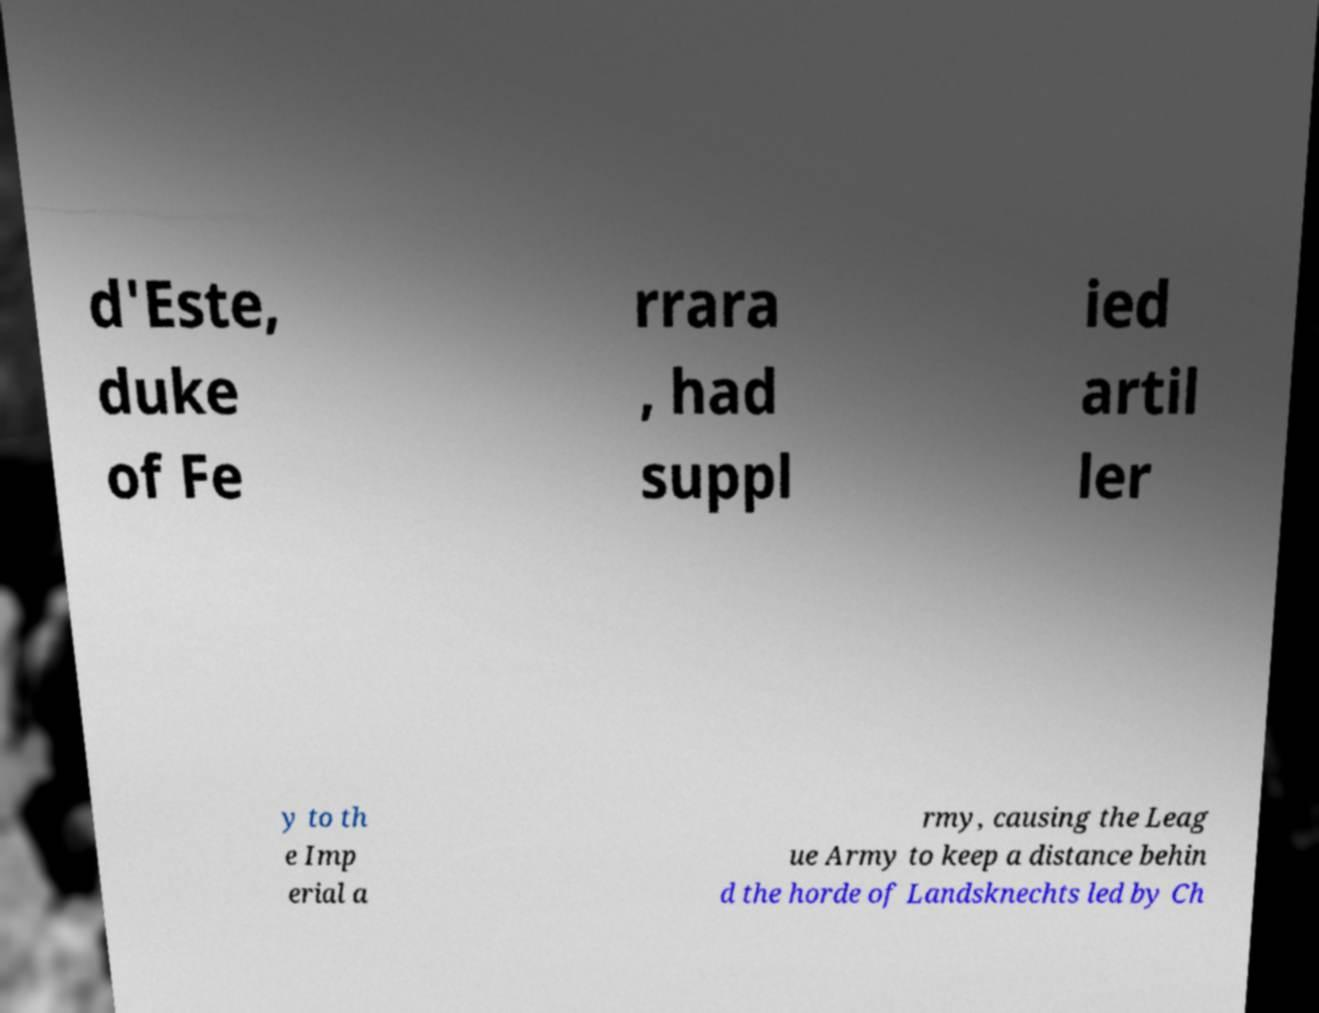For documentation purposes, I need the text within this image transcribed. Could you provide that? d'Este, duke of Fe rrara , had suppl ied artil ler y to th e Imp erial a rmy, causing the Leag ue Army to keep a distance behin d the horde of Landsknechts led by Ch 